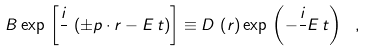<formula> <loc_0><loc_0><loc_500><loc_500>B \exp \, \left [ \frac { i } { } \, \left ( \pm { p } \cdot { r } - E \, t \right ) \right ] \equiv D \, \left ( { r } \right ) \exp \, \left ( - \frac { i } { } E \, t \right ) \ ,</formula> 